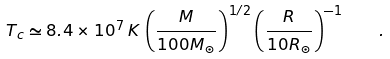Convert formula to latex. <formula><loc_0><loc_0><loc_500><loc_500>T _ { c } \simeq 8 . 4 \times 1 0 ^ { 7 } \, K \, \left ( \frac { M } { 1 0 0 M _ { \odot } } \right ) ^ { 1 / 2 } \left ( \frac { R } { 1 0 R _ { \odot } } \right ) ^ { - 1 } \quad .</formula> 